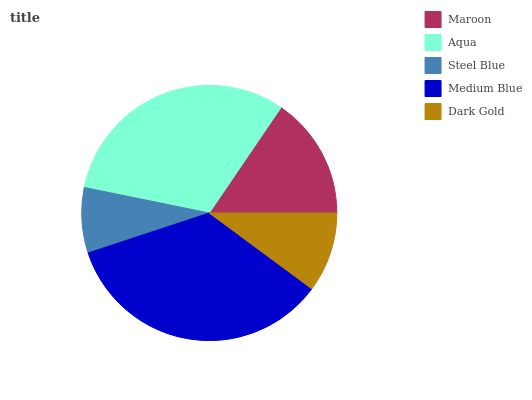Is Steel Blue the minimum?
Answer yes or no. Yes. Is Medium Blue the maximum?
Answer yes or no. Yes. Is Aqua the minimum?
Answer yes or no. No. Is Aqua the maximum?
Answer yes or no. No. Is Aqua greater than Maroon?
Answer yes or no. Yes. Is Maroon less than Aqua?
Answer yes or no. Yes. Is Maroon greater than Aqua?
Answer yes or no. No. Is Aqua less than Maroon?
Answer yes or no. No. Is Maroon the high median?
Answer yes or no. Yes. Is Maroon the low median?
Answer yes or no. Yes. Is Aqua the high median?
Answer yes or no. No. Is Steel Blue the low median?
Answer yes or no. No. 